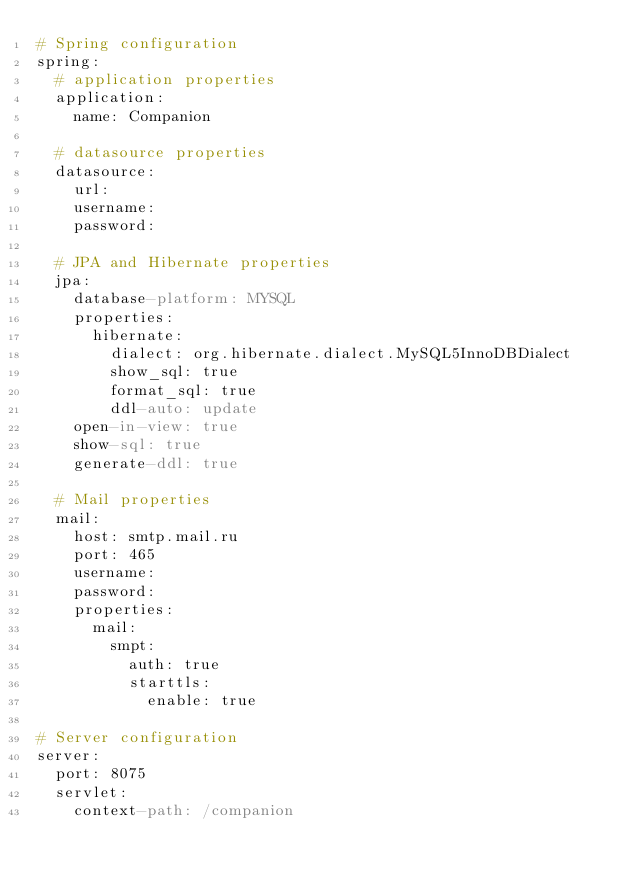<code> <loc_0><loc_0><loc_500><loc_500><_YAML_># Spring configuration
spring:
  # application properties
  application:
    name: Companion

  # datasource properties
  datasource:
    url: 
    username: 
    password: 

  # JPA and Hibernate properties
  jpa:
    database-platform: MYSQL
    properties:
      hibernate:
        dialect: org.hibernate.dialect.MySQL5InnoDBDialect
        show_sql: true
        format_sql: true
        ddl-auto: update
    open-in-view: true
    show-sql: true
    generate-ddl: true

  # Mail properties
  mail:
    host: smtp.mail.ru
    port: 465
    username: 
    password: 
    properties:
      mail:
        smpt:
          auth: true
          starttls:
            enable: true

# Server configuration
server:
  port: 8075
  servlet:
    context-path: /companion
</code> 